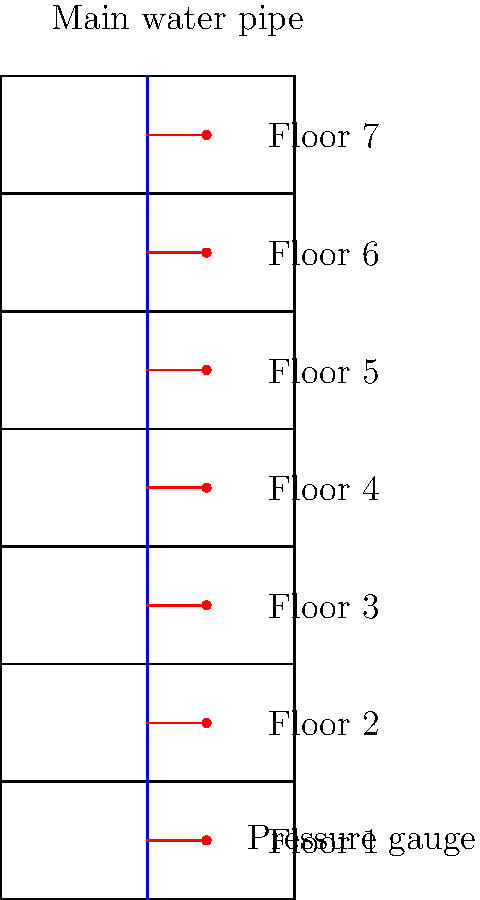A 7-story apartment building uses a central water supply system. The main water pipe runs vertically through all floors, with pressure gauges installed on each floor. If the water pressure at the ground floor (Floor 1) is 60 psi, and the pressure decreases by 0.43 psi per foot of height, calculate the water pressure at the top floor (Floor 7). Assume each floor is 12 feet high. To solve this problem, we'll follow these steps:

1. Calculate the total height difference between Floor 1 and Floor 7:
   - Number of floors between = 7 - 1 = 6
   - Height per floor = 12 feet
   - Total height difference = 6 × 12 = 72 feet

2. Calculate the pressure decrease over the total height:
   - Pressure decrease per foot = 0.43 psi
   - Total pressure decrease = 72 feet × 0.43 psi/foot = 30.96 psi

3. Calculate the pressure at Floor 7:
   - Initial pressure (Floor 1) = 60 psi
   - Pressure at Floor 7 = 60 psi - 30.96 psi = 29.04 psi

Therefore, the water pressure at the top floor (Floor 7) is approximately 29.04 psi.
Answer: 29.04 psi 